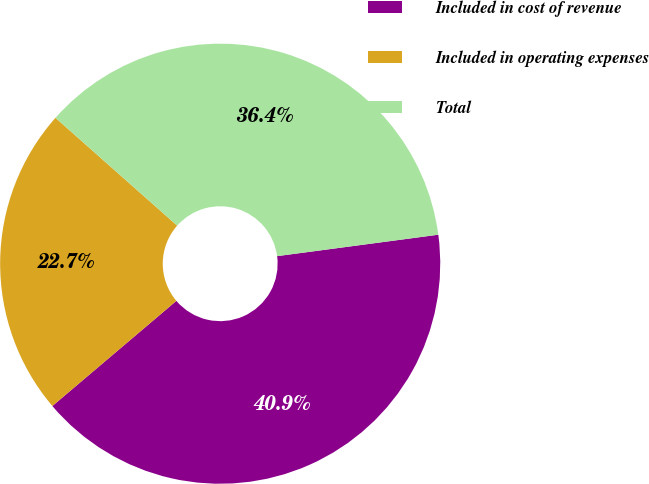Convert chart. <chart><loc_0><loc_0><loc_500><loc_500><pie_chart><fcel>Included in cost of revenue<fcel>Included in operating expenses<fcel>Total<nl><fcel>40.91%<fcel>22.73%<fcel>36.36%<nl></chart> 